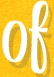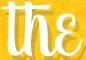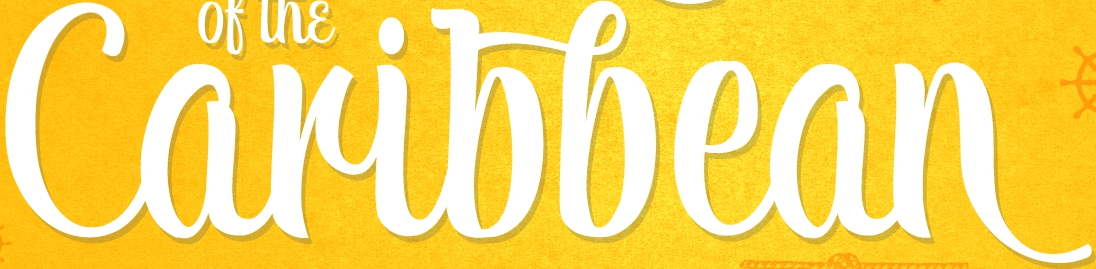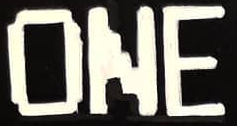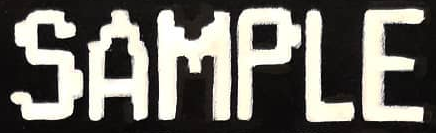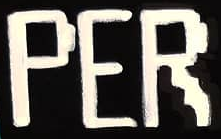Read the text from these images in sequence, separated by a semicolon. of; the; Caribbean; ONE; SAMPLE; PER 